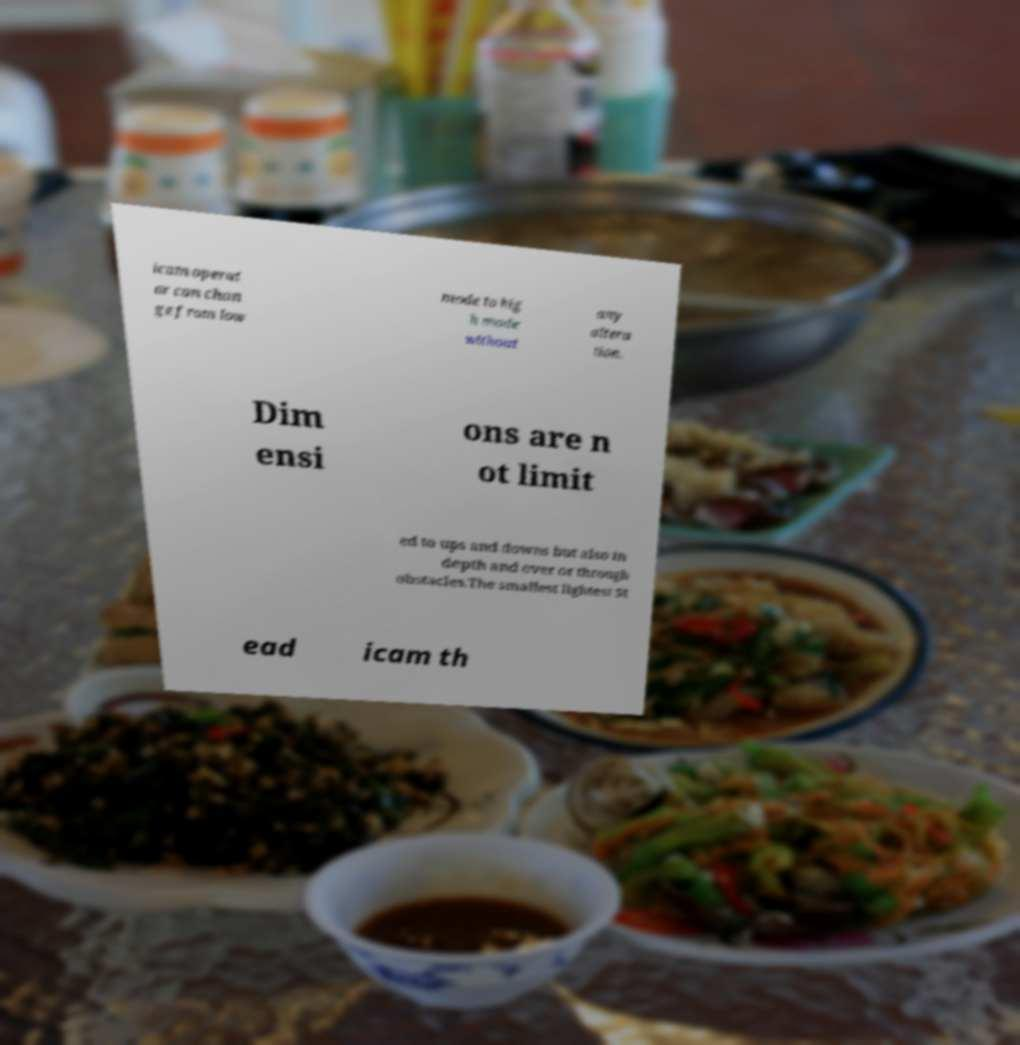Please read and relay the text visible in this image. What does it say? icam operat or can chan ge from low mode to hig h mode without any altera tion. Dim ensi ons are n ot limit ed to ups and downs but also in depth and over or through obstacles.The smallest lightest St ead icam th 